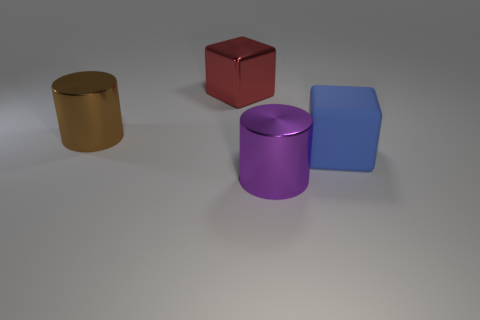There is a object that is both in front of the red metallic cube and left of the purple metal thing; what is its material?
Offer a terse response. Metal. Are there any matte cubes on the left side of the cylinder that is in front of the big blue matte cube?
Provide a short and direct response. No. How big is the object that is both right of the red metal thing and behind the large purple shiny thing?
Offer a terse response. Large. What number of brown objects are small shiny things or metal cylinders?
Your answer should be very brief. 1. The red metallic thing that is the same size as the brown cylinder is what shape?
Make the answer very short. Cube. How many other things are there of the same color as the metal cube?
Ensure brevity in your answer.  0. What size is the shiny cylinder to the left of the big cylinder that is in front of the matte cube?
Keep it short and to the point. Large. Are the big object in front of the matte thing and the brown cylinder made of the same material?
Your answer should be compact. Yes. There is a big shiny object that is in front of the large brown metal cylinder; what is its shape?
Your answer should be very brief. Cylinder. What number of purple metallic cylinders have the same size as the purple object?
Provide a succinct answer. 0. 